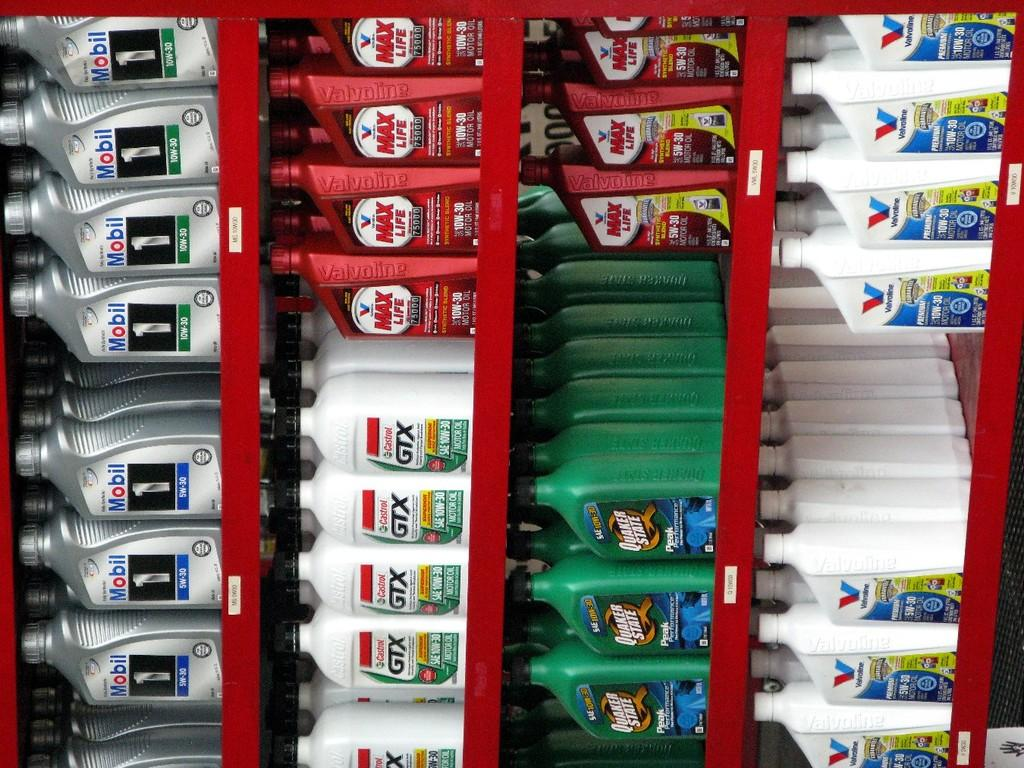<image>
Share a concise interpretation of the image provided. A red display case filled with various motor oils. 